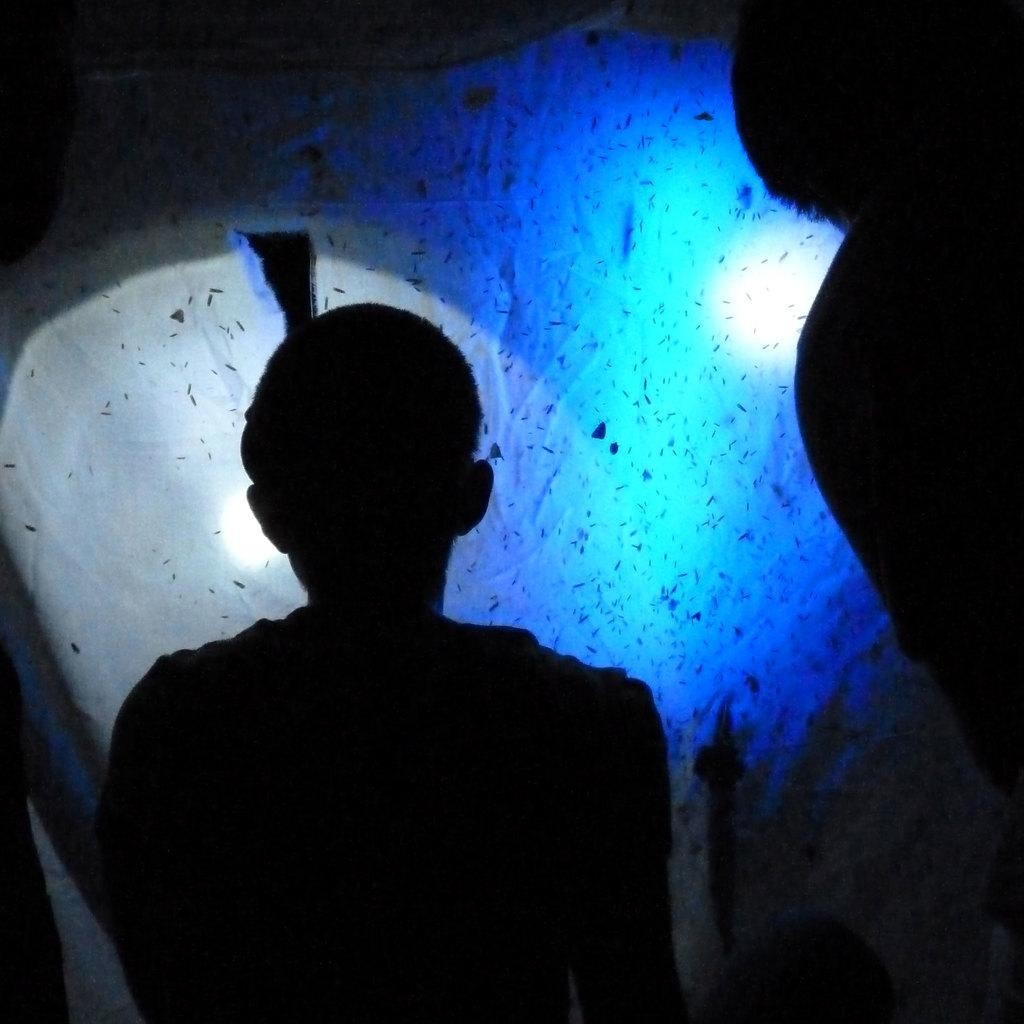What can be seen in the image that provides illumination? There are lights in the image. How many people are present in the image? There are two persons in the image. What type of loss is being experienced by the two persons in the image? There is no indication of any loss in the image; it simply shows two persons and lights. How does the harmony between the two persons in the image reflect their relationship with authority? There is no information about the relationship between the two persons and any authority figures in the image. 